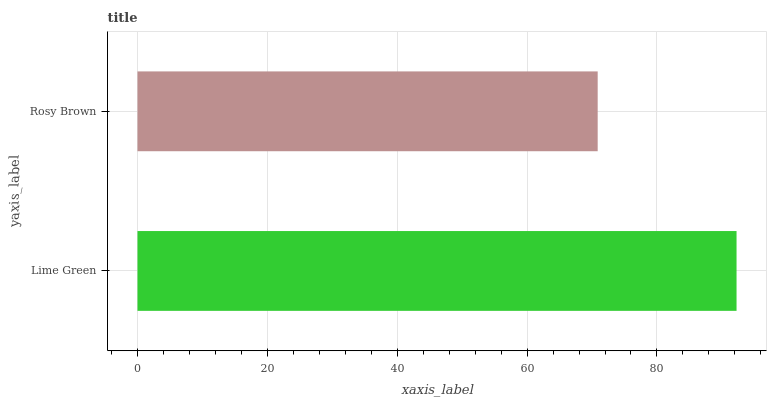Is Rosy Brown the minimum?
Answer yes or no. Yes. Is Lime Green the maximum?
Answer yes or no. Yes. Is Rosy Brown the maximum?
Answer yes or no. No. Is Lime Green greater than Rosy Brown?
Answer yes or no. Yes. Is Rosy Brown less than Lime Green?
Answer yes or no. Yes. Is Rosy Brown greater than Lime Green?
Answer yes or no. No. Is Lime Green less than Rosy Brown?
Answer yes or no. No. Is Lime Green the high median?
Answer yes or no. Yes. Is Rosy Brown the low median?
Answer yes or no. Yes. Is Rosy Brown the high median?
Answer yes or no. No. Is Lime Green the low median?
Answer yes or no. No. 